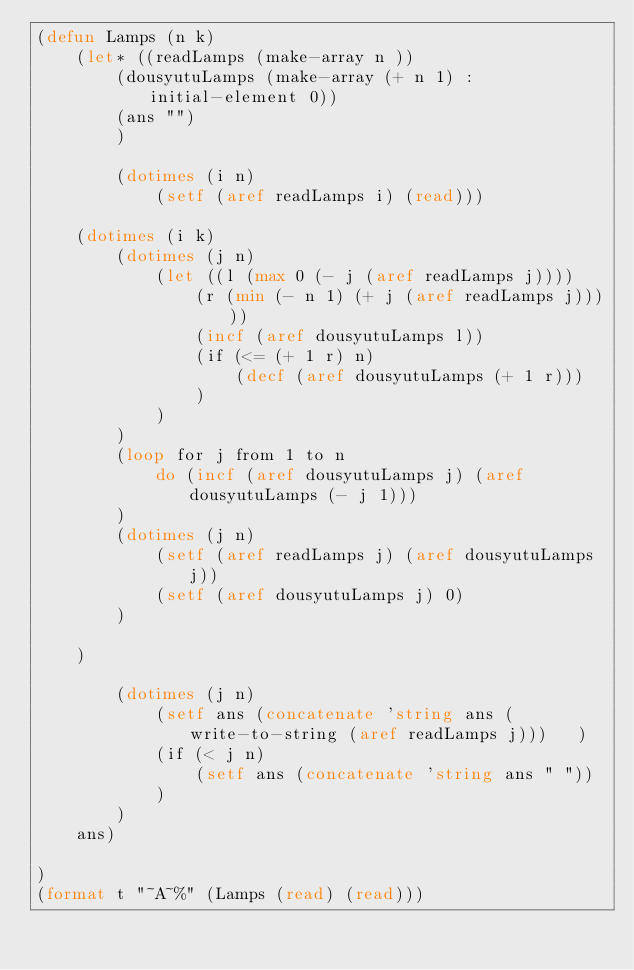<code> <loc_0><loc_0><loc_500><loc_500><_Lisp_>(defun Lamps (n k)
    (let* ((readLamps (make-array n ))
        (dousyutuLamps (make-array (+ n 1) :initial-element 0))
        (ans "")
        )

        (dotimes (i n) 
            (setf (aref readLamps i) (read)))

    (dotimes (i k)
        (dotimes (j n)
            (let ((l (max 0 (- j (aref readLamps j))))
                (r (min (- n 1) (+ j (aref readLamps j)))))
                (incf (aref dousyutuLamps l))
                (if (<= (+ 1 r) n)
                    (decf (aref dousyutuLamps (+ 1 r)))
                )
            )                    
        )
        (loop for j from 1 to n
            do (incf (aref dousyutuLamps j) (aref dousyutuLamps (- j 1)))
        )
        (dotimes (j n)
            (setf (aref readLamps j) (aref dousyutuLamps j))
            (setf (aref dousyutuLamps j) 0)
        ) 
        
    )

        (dotimes (j n)
            (setf ans (concatenate 'string ans (write-to-string (aref readLamps j)))   )
            (if (< j n)
                (setf ans (concatenate 'string ans " "))
            )
        )
    ans)
    
)
(format t "~A~%" (Lamps (read) (read)))</code> 